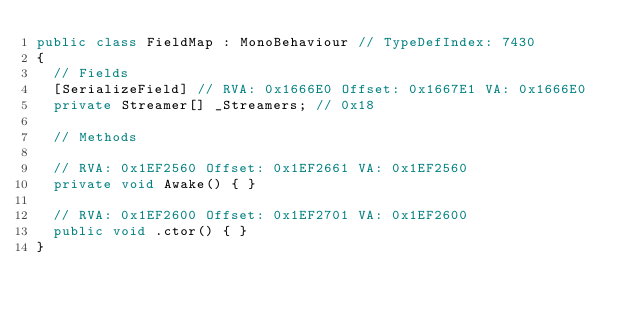Convert code to text. <code><loc_0><loc_0><loc_500><loc_500><_C#_>public class FieldMap : MonoBehaviour // TypeDefIndex: 7430
{
	// Fields
	[SerializeField] // RVA: 0x1666E0 Offset: 0x1667E1 VA: 0x1666E0
	private Streamer[] _Streamers; // 0x18

	// Methods

	// RVA: 0x1EF2560 Offset: 0x1EF2661 VA: 0x1EF2560
	private void Awake() { }

	// RVA: 0x1EF2600 Offset: 0x1EF2701 VA: 0x1EF2600
	public void .ctor() { }
}

</code> 